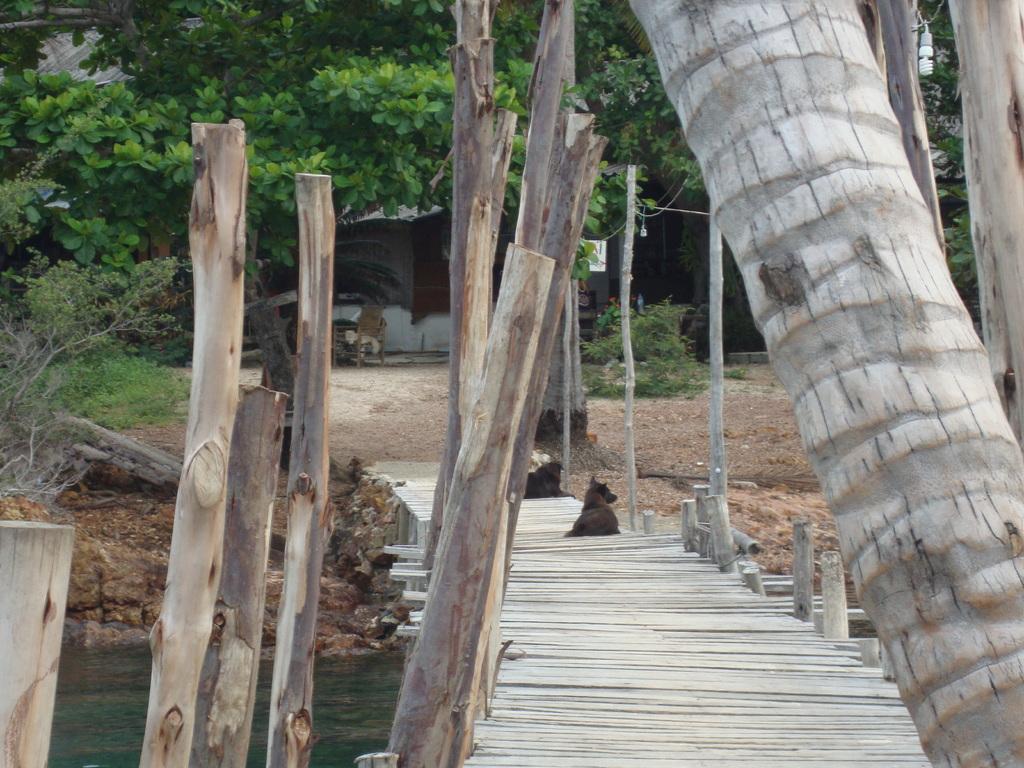In one or two sentences, can you explain what this image depicts? In this image in the front there is a tree trunk and on the left side there are wooden logs. In the center there is a dog sitting on a bridge and under the bridge there is water. In the background there are plants, trees and there is a building. 